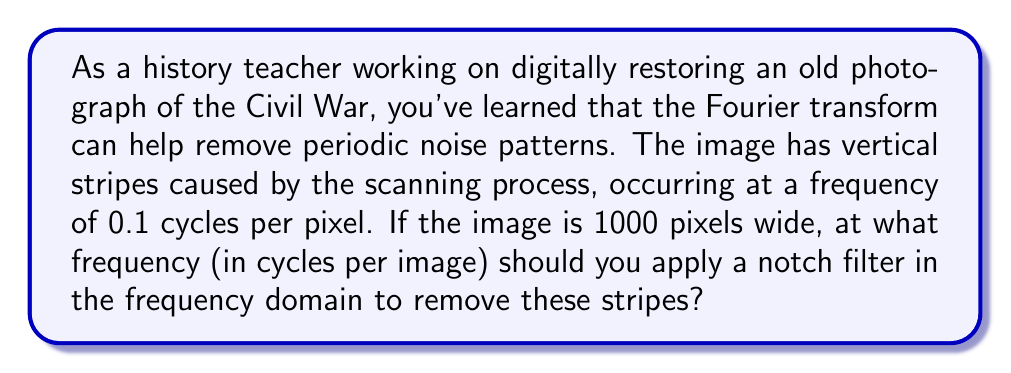Teach me how to tackle this problem. To solve this problem, we need to understand the relationship between frequency in cycles per pixel and cycles per image. Let's break it down step-by-step:

1) We're given that the stripe frequency is 0.1 cycles per pixel.

2) The image width is 1000 pixels.

3) To convert from cycles per pixel to cycles per image, we multiply the frequency by the image width:

   $$f_{image} = f_{pixel} \times \text{image width}$$

4) Substituting our values:

   $$f_{image} = 0.1 \text{ cycles/pixel} \times 1000 \text{ pixels}$$

5) Simplifying:

   $$f_{image} = 100 \text{ cycles/image}$$

This means that the stripes complete 100 cycles across the entire width of the image.

In the frequency domain of the Fourier transform, this periodic noise will appear as peaks at ±100 cycles per image. To remove these stripes, you would apply a notch filter at these frequencies.
Answer: 100 cycles per image 